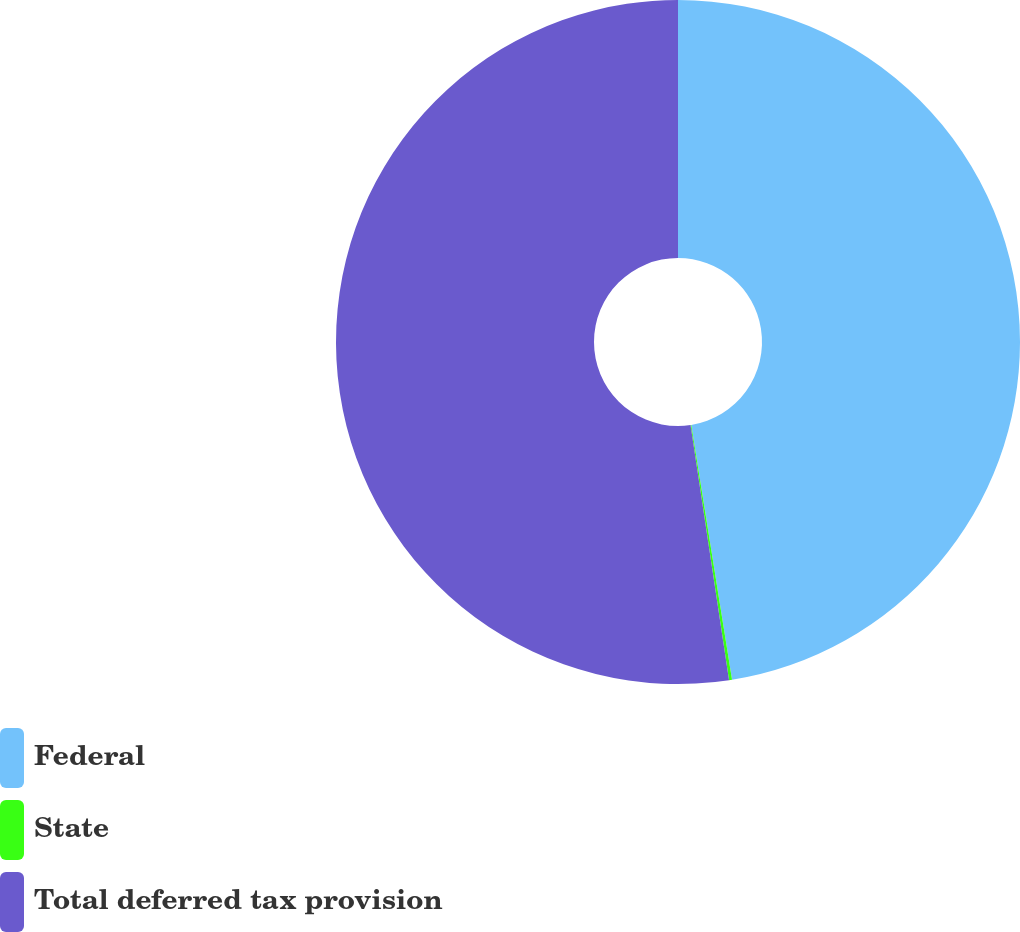Convert chart to OTSL. <chart><loc_0><loc_0><loc_500><loc_500><pie_chart><fcel>Federal<fcel>State<fcel>Total deferred tax provision<nl><fcel>47.47%<fcel>0.14%<fcel>52.38%<nl></chart> 